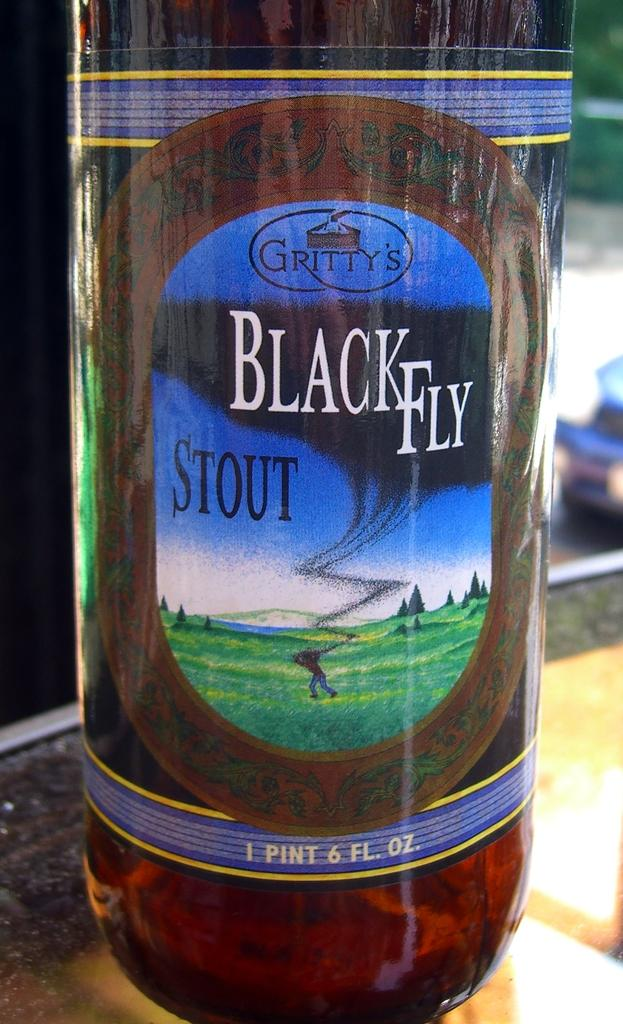What object can be seen in the image? There is a bottle in the image. What feature is present on the bottle? The bottle has a label attached to it. What information is provided on the label? There is text written on the label. Where is the bottle located in the image? The bottle is placed on a table. How many chickens are sitting on the table next to the bottle in the image? There are no chickens present in the image; it only features a bottle with a label on a table. 